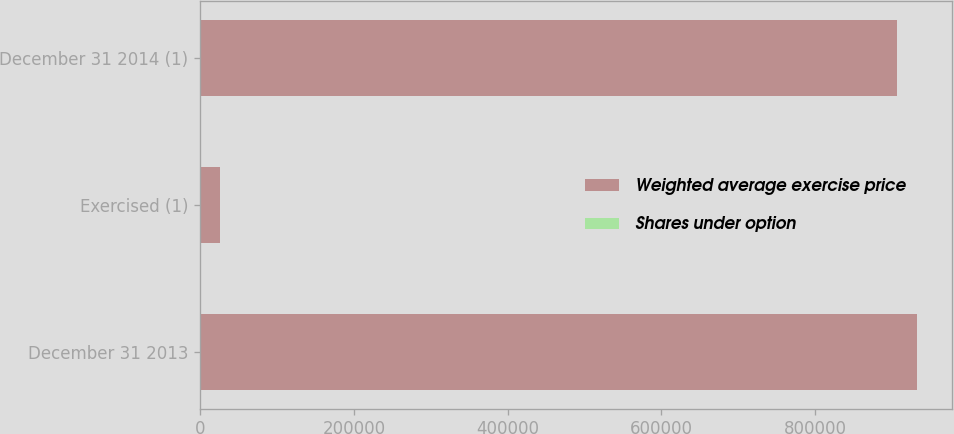Convert chart. <chart><loc_0><loc_0><loc_500><loc_500><stacked_bar_chart><ecel><fcel>December 31 2013<fcel>Exercised (1)<fcel>December 31 2014 (1)<nl><fcel>Weighted average exercise price<fcel>931758<fcel>25039<fcel>906719<nl><fcel>Shares under option<fcel>167.76<fcel>167.76<fcel>167.76<nl></chart> 